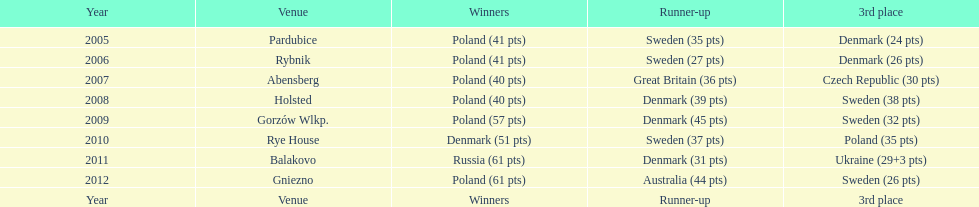In the speedway junior world championship, which team achieved the most third-place victories from 2005 to 2012? Sweden. 